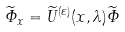Convert formula to latex. <formula><loc_0><loc_0><loc_500><loc_500>\widetilde { \varPhi } _ { x } = \widetilde { U } ^ { ( \varepsilon ) } ( x , \lambda ) \widetilde { \varPhi }</formula> 